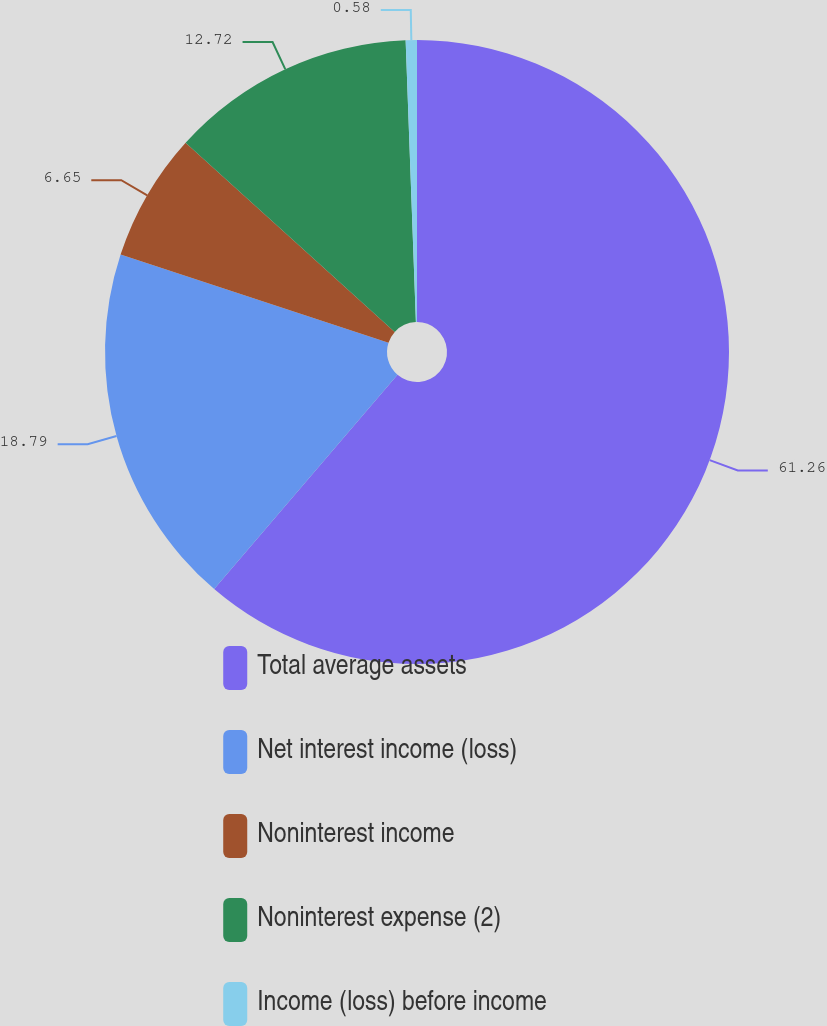Convert chart to OTSL. <chart><loc_0><loc_0><loc_500><loc_500><pie_chart><fcel>Total average assets<fcel>Net interest income (loss)<fcel>Noninterest income<fcel>Noninterest expense (2)<fcel>Income (loss) before income<nl><fcel>61.27%<fcel>18.79%<fcel>6.65%<fcel>12.72%<fcel>0.58%<nl></chart> 